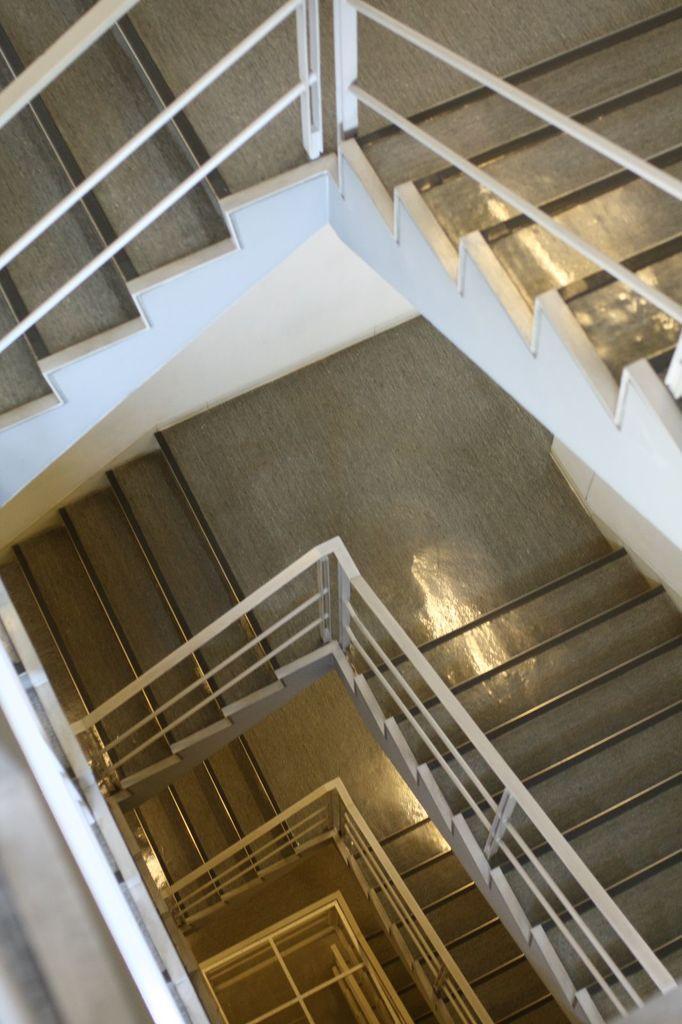Can you describe this image briefly? In the image there is some floor of staircase with many steps. 